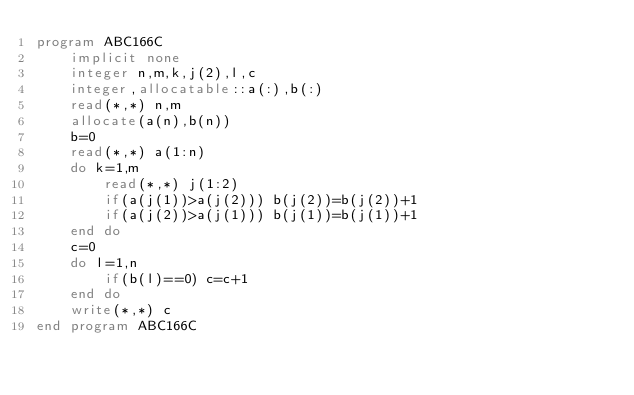Convert code to text. <code><loc_0><loc_0><loc_500><loc_500><_FORTRAN_>program ABC166C
    implicit none
    integer n,m,k,j(2),l,c
    integer,allocatable::a(:),b(:)
    read(*,*) n,m
    allocate(a(n),b(n))
    b=0
    read(*,*) a(1:n)
    do k=1,m
        read(*,*) j(1:2)
        if(a(j(1))>a(j(2))) b(j(2))=b(j(2))+1
        if(a(j(2))>a(j(1))) b(j(1))=b(j(1))+1
    end do
    c=0
    do l=1,n
        if(b(l)==0) c=c+1
    end do
    write(*,*) c
end program ABC166C</code> 